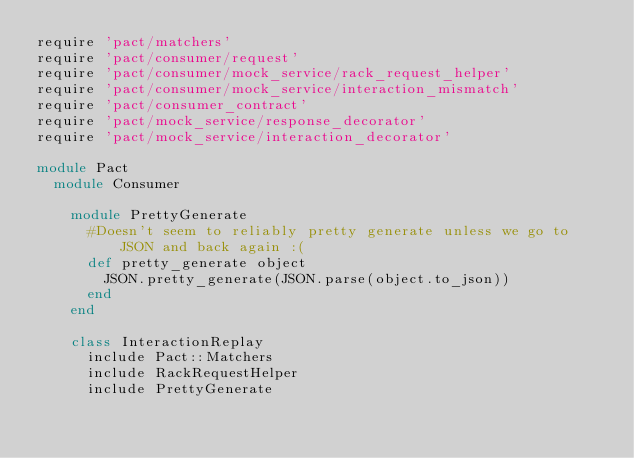Convert code to text. <code><loc_0><loc_0><loc_500><loc_500><_Ruby_>require 'pact/matchers'
require 'pact/consumer/request'
require 'pact/consumer/mock_service/rack_request_helper'
require 'pact/consumer/mock_service/interaction_mismatch'
require 'pact/consumer_contract'
require 'pact/mock_service/response_decorator'
require 'pact/mock_service/interaction_decorator'

module Pact
  module Consumer

    module PrettyGenerate
      #Doesn't seem to reliably pretty generate unless we go to JSON and back again :(
      def pretty_generate object
        JSON.pretty_generate(JSON.parse(object.to_json))
      end
    end

    class InteractionReplay
      include Pact::Matchers
      include RackRequestHelper
      include PrettyGenerate
</code> 